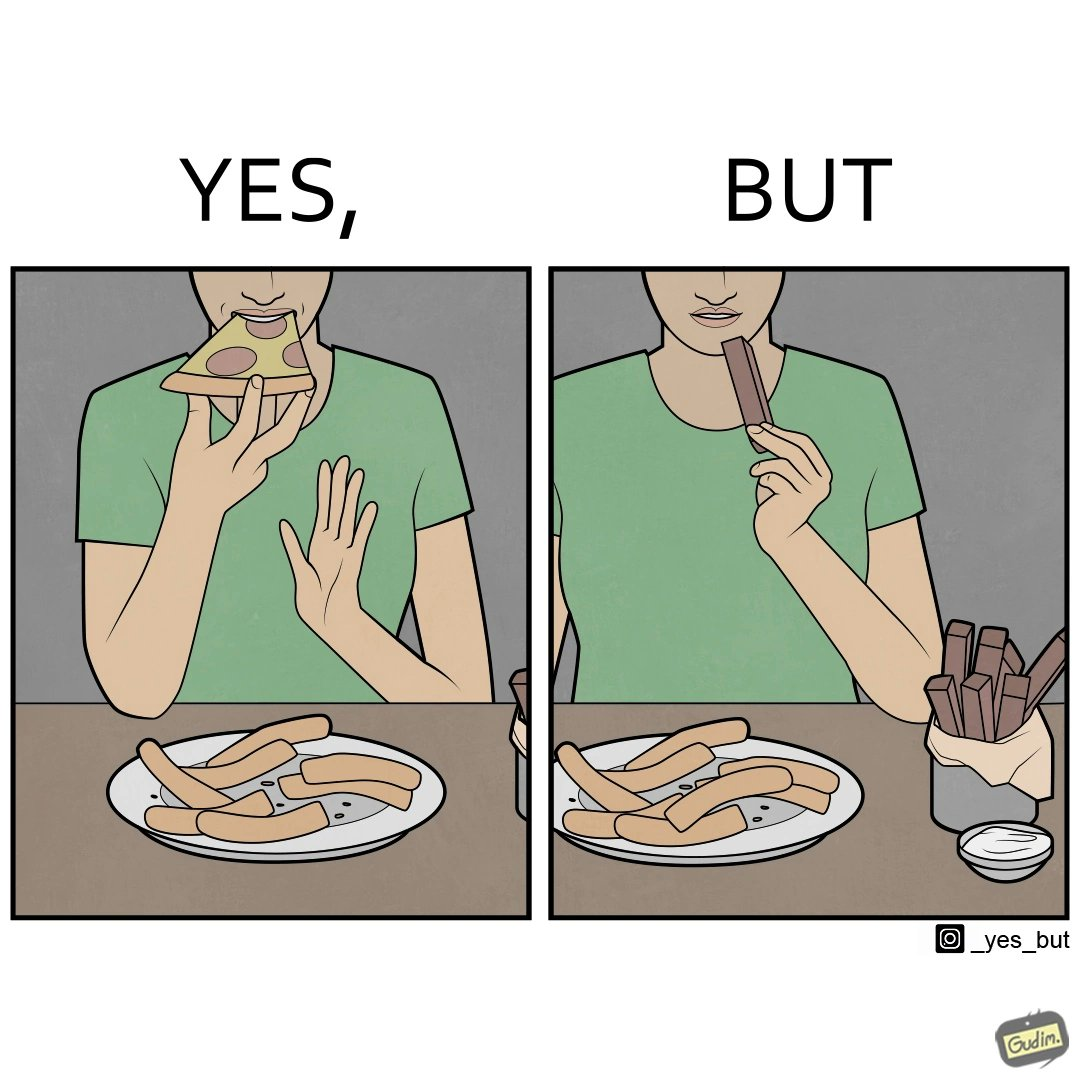Does this image contain satire or humor? Yes, this image is satirical. 